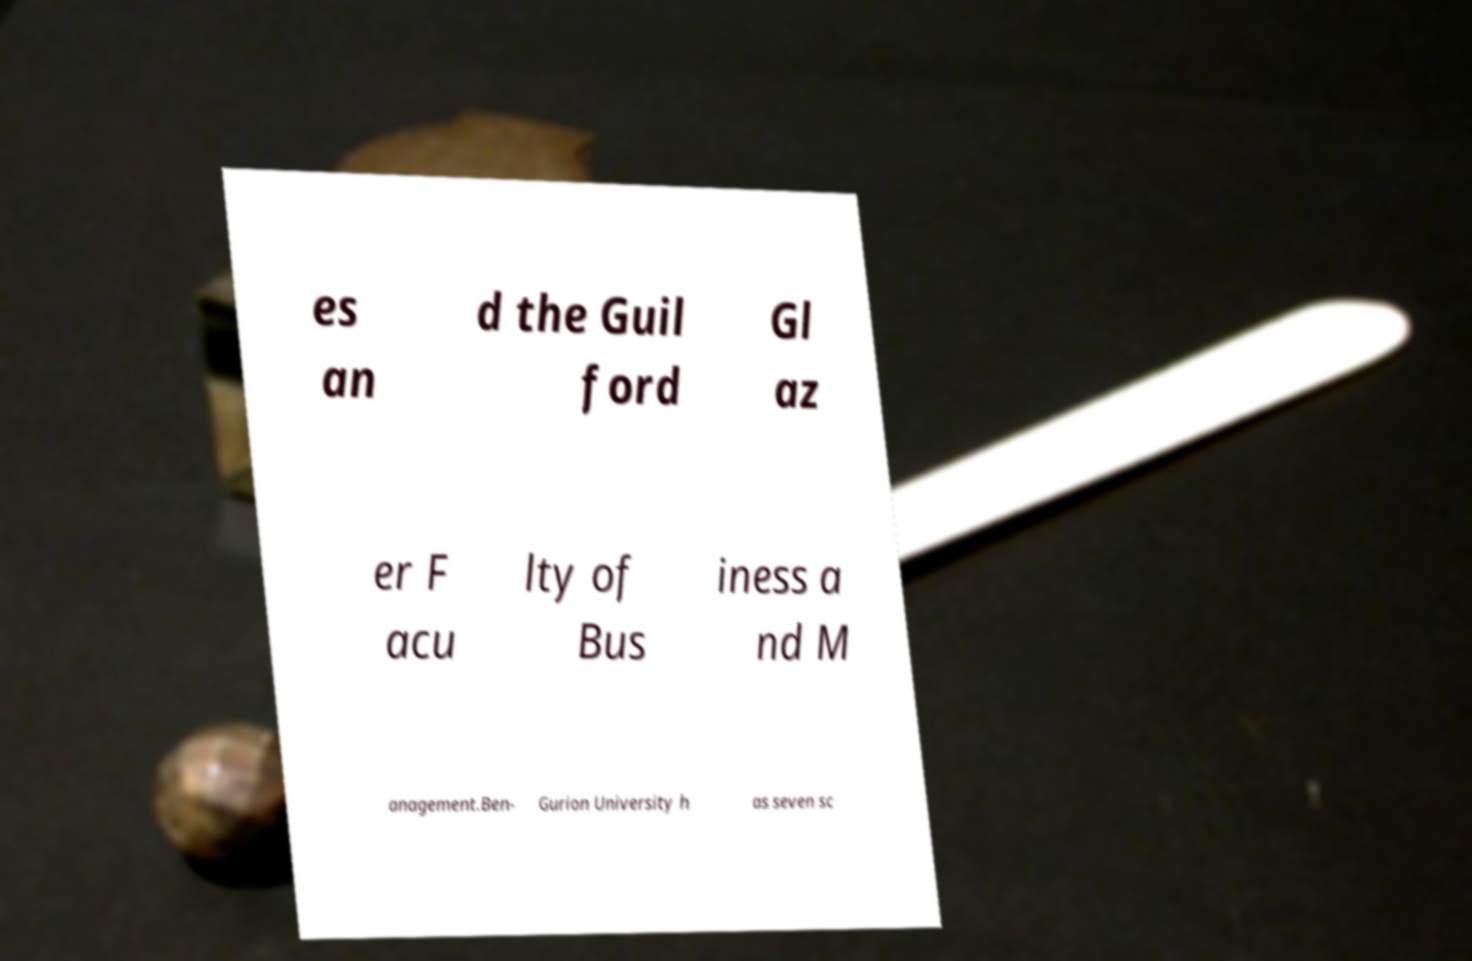Could you extract and type out the text from this image? es an d the Guil ford Gl az er F acu lty of Bus iness a nd M anagement.Ben- Gurion University h as seven sc 